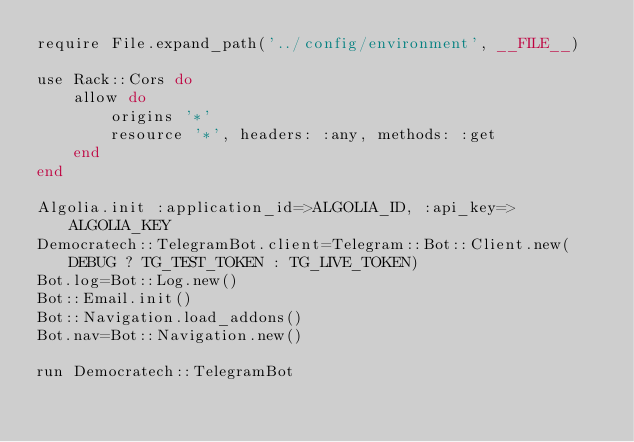<code> <loc_0><loc_0><loc_500><loc_500><_Ruby_>require File.expand_path('../config/environment', __FILE__)

use Rack::Cors do
	allow do
		origins '*'
		resource '*', headers: :any, methods: :get
	end
end

Algolia.init :application_id=>ALGOLIA_ID, :api_key=>ALGOLIA_KEY
Democratech::TelegramBot.client=Telegram::Bot::Client.new(DEBUG ? TG_TEST_TOKEN : TG_LIVE_TOKEN)
Bot.log=Bot::Log.new()
Bot::Email.init()
Bot::Navigation.load_addons()
Bot.nav=Bot::Navigation.new()

run Democratech::TelegramBot
</code> 